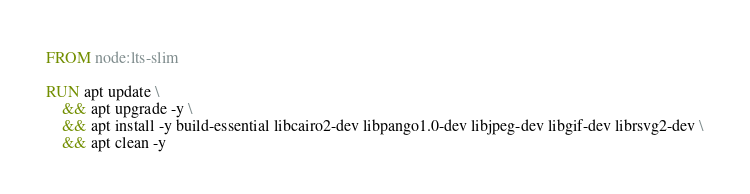<code> <loc_0><loc_0><loc_500><loc_500><_Dockerfile_>FROM node:lts-slim

RUN apt update \
    && apt upgrade -y \
    && apt install -y build-essential libcairo2-dev libpango1.0-dev libjpeg-dev libgif-dev librsvg2-dev \
    && apt clean -y
</code> 